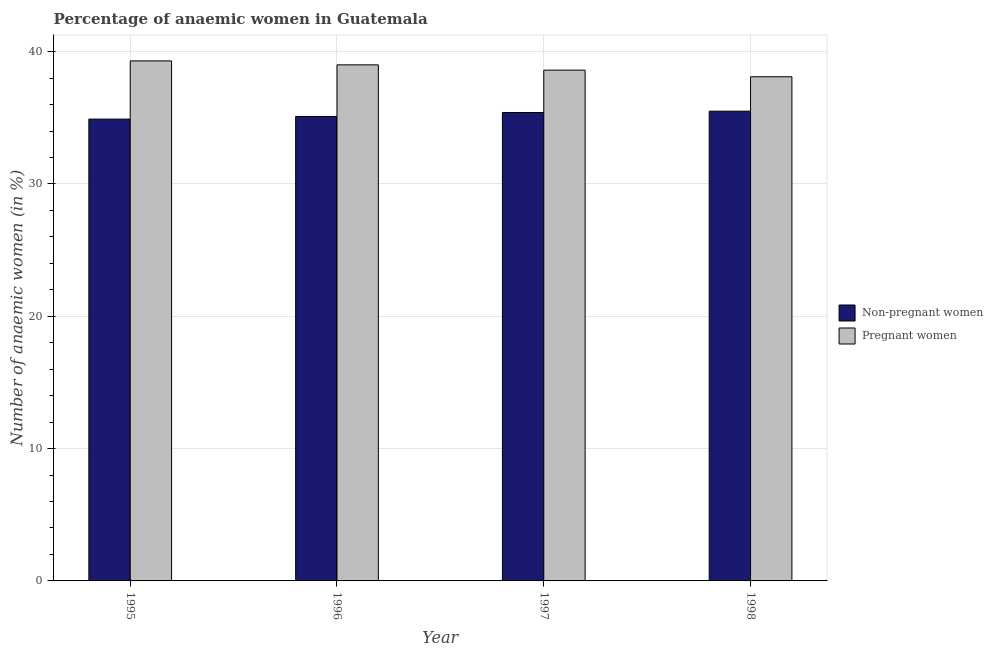How many bars are there on the 3rd tick from the left?
Keep it short and to the point. 2. Across all years, what is the maximum percentage of non-pregnant anaemic women?
Your response must be concise. 35.5. Across all years, what is the minimum percentage of non-pregnant anaemic women?
Keep it short and to the point. 34.9. In which year was the percentage of pregnant anaemic women minimum?
Offer a very short reply. 1998. What is the total percentage of pregnant anaemic women in the graph?
Provide a short and direct response. 155. What is the difference between the percentage of pregnant anaemic women in 1996 and that in 1997?
Your response must be concise. 0.4. What is the difference between the percentage of non-pregnant anaemic women in 1997 and the percentage of pregnant anaemic women in 1998?
Keep it short and to the point. -0.1. What is the average percentage of pregnant anaemic women per year?
Provide a short and direct response. 38.75. In the year 1995, what is the difference between the percentage of non-pregnant anaemic women and percentage of pregnant anaemic women?
Your answer should be very brief. 0. In how many years, is the percentage of non-pregnant anaemic women greater than 32 %?
Keep it short and to the point. 4. What is the ratio of the percentage of pregnant anaemic women in 1995 to that in 1997?
Ensure brevity in your answer.  1.02. Is the difference between the percentage of pregnant anaemic women in 1995 and 1998 greater than the difference between the percentage of non-pregnant anaemic women in 1995 and 1998?
Your answer should be very brief. No. What is the difference between the highest and the second highest percentage of non-pregnant anaemic women?
Keep it short and to the point. 0.1. What is the difference between the highest and the lowest percentage of pregnant anaemic women?
Offer a terse response. 1.2. In how many years, is the percentage of pregnant anaemic women greater than the average percentage of pregnant anaemic women taken over all years?
Offer a terse response. 2. Is the sum of the percentage of non-pregnant anaemic women in 1995 and 1996 greater than the maximum percentage of pregnant anaemic women across all years?
Make the answer very short. Yes. What does the 2nd bar from the left in 1998 represents?
Keep it short and to the point. Pregnant women. What does the 1st bar from the right in 1995 represents?
Give a very brief answer. Pregnant women. Are all the bars in the graph horizontal?
Keep it short and to the point. No. How many years are there in the graph?
Give a very brief answer. 4. What is the difference between two consecutive major ticks on the Y-axis?
Provide a short and direct response. 10. Are the values on the major ticks of Y-axis written in scientific E-notation?
Give a very brief answer. No. Does the graph contain grids?
Offer a very short reply. Yes. Where does the legend appear in the graph?
Provide a succinct answer. Center right. How are the legend labels stacked?
Offer a very short reply. Vertical. What is the title of the graph?
Provide a short and direct response. Percentage of anaemic women in Guatemala. What is the label or title of the Y-axis?
Offer a very short reply. Number of anaemic women (in %). What is the Number of anaemic women (in %) of Non-pregnant women in 1995?
Give a very brief answer. 34.9. What is the Number of anaemic women (in %) of Pregnant women in 1995?
Offer a terse response. 39.3. What is the Number of anaemic women (in %) in Non-pregnant women in 1996?
Your answer should be compact. 35.1. What is the Number of anaemic women (in %) of Non-pregnant women in 1997?
Keep it short and to the point. 35.4. What is the Number of anaemic women (in %) of Pregnant women in 1997?
Provide a short and direct response. 38.6. What is the Number of anaemic women (in %) in Non-pregnant women in 1998?
Make the answer very short. 35.5. What is the Number of anaemic women (in %) of Pregnant women in 1998?
Offer a terse response. 38.1. Across all years, what is the maximum Number of anaemic women (in %) of Non-pregnant women?
Your answer should be compact. 35.5. Across all years, what is the maximum Number of anaemic women (in %) of Pregnant women?
Make the answer very short. 39.3. Across all years, what is the minimum Number of anaemic women (in %) in Non-pregnant women?
Offer a terse response. 34.9. Across all years, what is the minimum Number of anaemic women (in %) of Pregnant women?
Provide a succinct answer. 38.1. What is the total Number of anaemic women (in %) of Non-pregnant women in the graph?
Give a very brief answer. 140.9. What is the total Number of anaemic women (in %) of Pregnant women in the graph?
Provide a succinct answer. 155. What is the difference between the Number of anaemic women (in %) in Non-pregnant women in 1995 and that in 1996?
Keep it short and to the point. -0.2. What is the difference between the Number of anaemic women (in %) of Pregnant women in 1995 and that in 1996?
Your answer should be compact. 0.3. What is the difference between the Number of anaemic women (in %) of Pregnant women in 1995 and that in 1997?
Your response must be concise. 0.7. What is the difference between the Number of anaemic women (in %) of Non-pregnant women in 1995 and that in 1998?
Give a very brief answer. -0.6. What is the difference between the Number of anaemic women (in %) of Pregnant women in 1995 and that in 1998?
Keep it short and to the point. 1.2. What is the difference between the Number of anaemic women (in %) of Pregnant women in 1996 and that in 1997?
Your answer should be very brief. 0.4. What is the difference between the Number of anaemic women (in %) in Non-pregnant women in 1996 and that in 1998?
Keep it short and to the point. -0.4. What is the difference between the Number of anaemic women (in %) of Non-pregnant women in 1997 and that in 1998?
Offer a very short reply. -0.1. What is the difference between the Number of anaemic women (in %) in Pregnant women in 1997 and that in 1998?
Offer a very short reply. 0.5. What is the difference between the Number of anaemic women (in %) of Non-pregnant women in 1996 and the Number of anaemic women (in %) of Pregnant women in 1998?
Keep it short and to the point. -3. What is the average Number of anaemic women (in %) of Non-pregnant women per year?
Offer a terse response. 35.23. What is the average Number of anaemic women (in %) in Pregnant women per year?
Ensure brevity in your answer.  38.75. What is the ratio of the Number of anaemic women (in %) of Non-pregnant women in 1995 to that in 1996?
Ensure brevity in your answer.  0.99. What is the ratio of the Number of anaemic women (in %) of Pregnant women in 1995 to that in 1996?
Your answer should be compact. 1.01. What is the ratio of the Number of anaemic women (in %) in Non-pregnant women in 1995 to that in 1997?
Keep it short and to the point. 0.99. What is the ratio of the Number of anaemic women (in %) in Pregnant women in 1995 to that in 1997?
Offer a very short reply. 1.02. What is the ratio of the Number of anaemic women (in %) in Non-pregnant women in 1995 to that in 1998?
Give a very brief answer. 0.98. What is the ratio of the Number of anaemic women (in %) of Pregnant women in 1995 to that in 1998?
Your answer should be compact. 1.03. What is the ratio of the Number of anaemic women (in %) of Non-pregnant women in 1996 to that in 1997?
Make the answer very short. 0.99. What is the ratio of the Number of anaemic women (in %) of Pregnant women in 1996 to that in 1997?
Offer a terse response. 1.01. What is the ratio of the Number of anaemic women (in %) in Non-pregnant women in 1996 to that in 1998?
Give a very brief answer. 0.99. What is the ratio of the Number of anaemic women (in %) of Pregnant women in 1996 to that in 1998?
Make the answer very short. 1.02. What is the ratio of the Number of anaemic women (in %) of Pregnant women in 1997 to that in 1998?
Your response must be concise. 1.01. What is the difference between the highest and the second highest Number of anaemic women (in %) of Non-pregnant women?
Keep it short and to the point. 0.1. What is the difference between the highest and the lowest Number of anaemic women (in %) of Non-pregnant women?
Your answer should be compact. 0.6. 